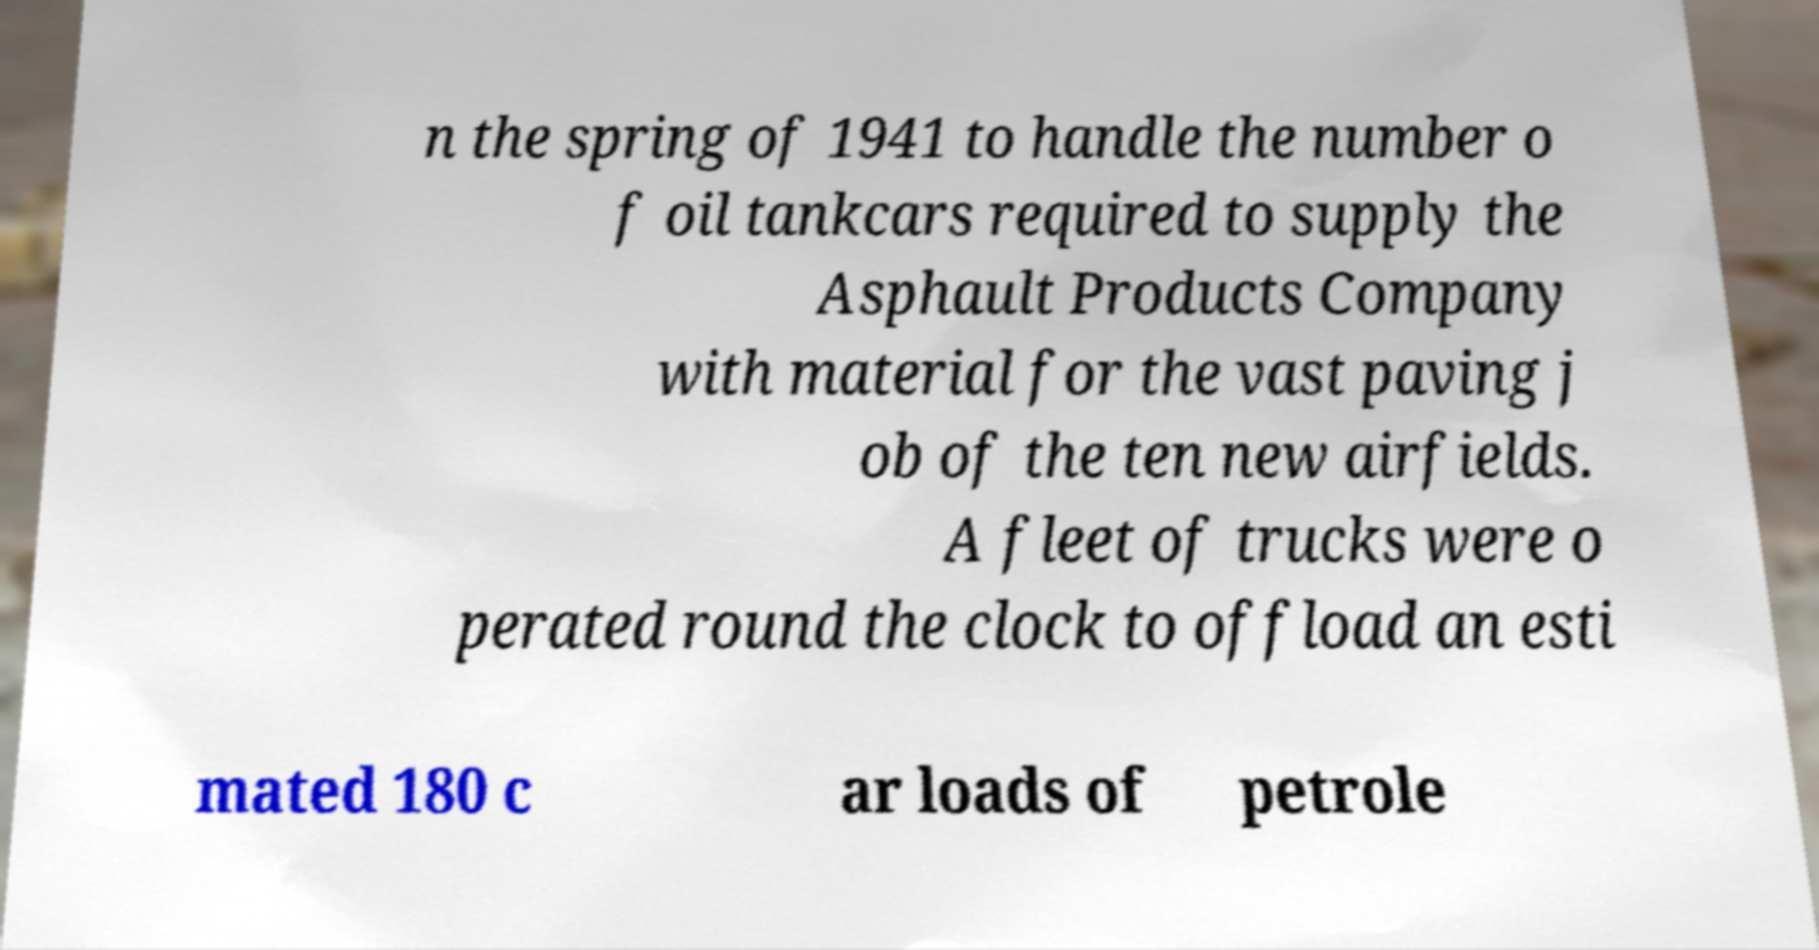I need the written content from this picture converted into text. Can you do that? n the spring of 1941 to handle the number o f oil tankcars required to supply the Asphault Products Company with material for the vast paving j ob of the ten new airfields. A fleet of trucks were o perated round the clock to offload an esti mated 180 c ar loads of petrole 